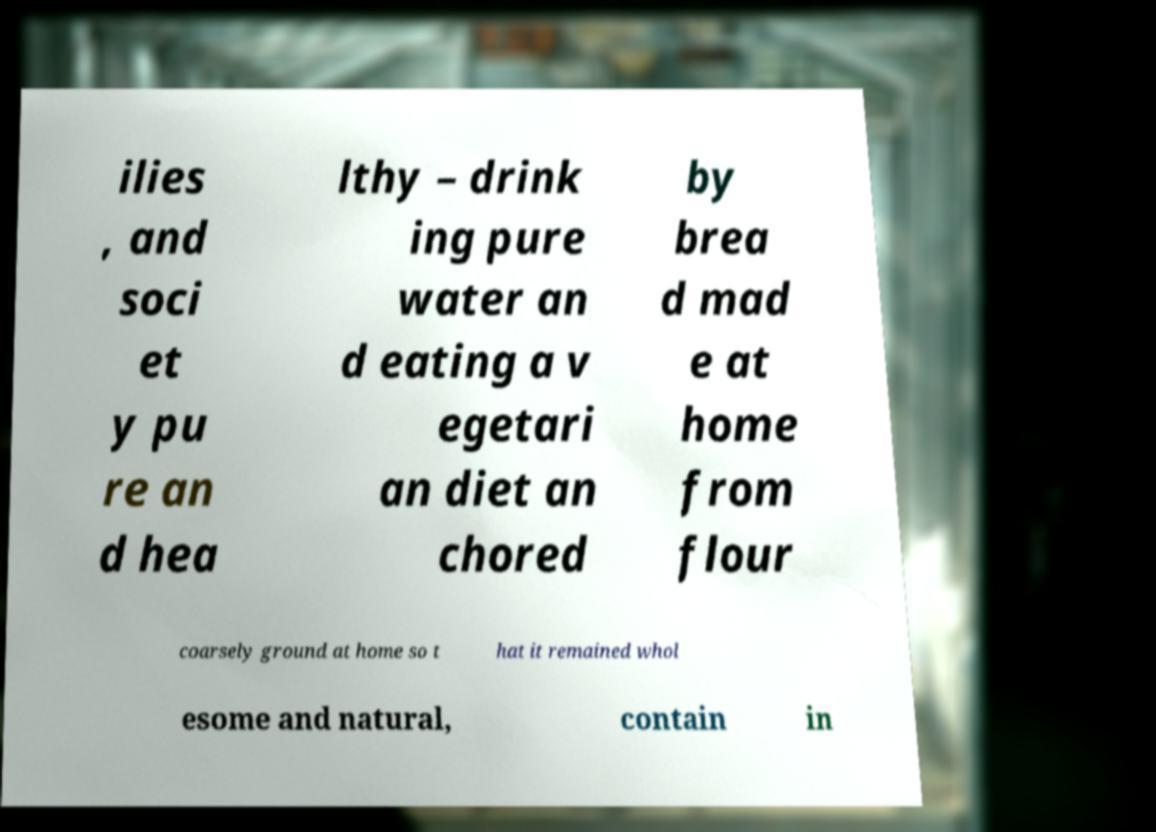I need the written content from this picture converted into text. Can you do that? ilies , and soci et y pu re an d hea lthy – drink ing pure water an d eating a v egetari an diet an chored by brea d mad e at home from flour coarsely ground at home so t hat it remained whol esome and natural, contain in 